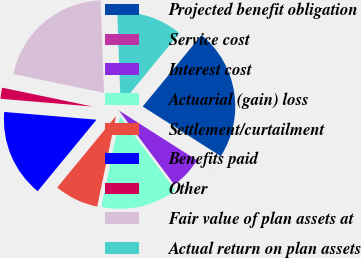<chart> <loc_0><loc_0><loc_500><loc_500><pie_chart><fcel>Projected benefit obligation<fcel>Service cost<fcel>Interest cost<fcel>Actuarial (gain) loss<fcel>Settlement/curtailment<fcel>Benefits paid<fcel>Other<fcel>Fair value of plan assets at<fcel>Actual return on plan assets<nl><fcel>23.07%<fcel>0.01%<fcel>5.77%<fcel>13.46%<fcel>7.7%<fcel>15.38%<fcel>1.93%<fcel>21.15%<fcel>11.54%<nl></chart> 